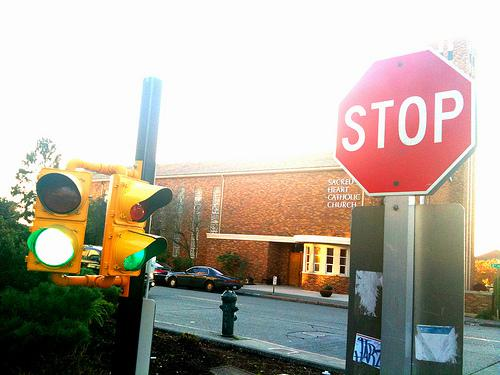Question: what is the building in the background made of?
Choices:
A. Wood.
B. Hay.
C. Brick.
D. Plaster.
Answer with the letter. Answer: C Question: what color light is shining on the left?
Choices:
A. Pink.
B. Green.
C. Purple.
D. Blue.
Answer with the letter. Answer: B Question: what kind of sign is on the right?
Choices:
A. A stop sign.
B. A restaurant sign.
C. Open sign.
D. Caution.
Answer with the letter. Answer: A Question: how many green lights are visible?
Choices:
A. Four.
B. Two.
C. Three.
D. One.
Answer with the letter. Answer: B Question: where was the picture taken?
Choices:
A. Near the Junior High School.
B. Near the Performing Arts Center.
C. Near the Memorial Coliseum.
D. Near the Sacred Heart Catholic Church.
Answer with the letter. Answer: D 